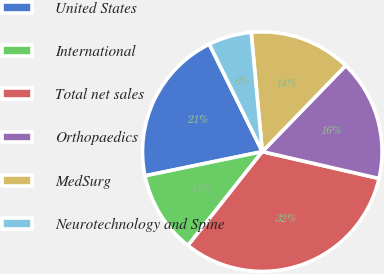Convert chart to OTSL. <chart><loc_0><loc_0><loc_500><loc_500><pie_chart><fcel>United States<fcel>International<fcel>Total net sales<fcel>Orthopaedics<fcel>MedSurg<fcel>Neurotechnology and Spine<nl><fcel>20.95%<fcel>11.1%<fcel>32.05%<fcel>16.35%<fcel>13.73%<fcel>5.81%<nl></chart> 